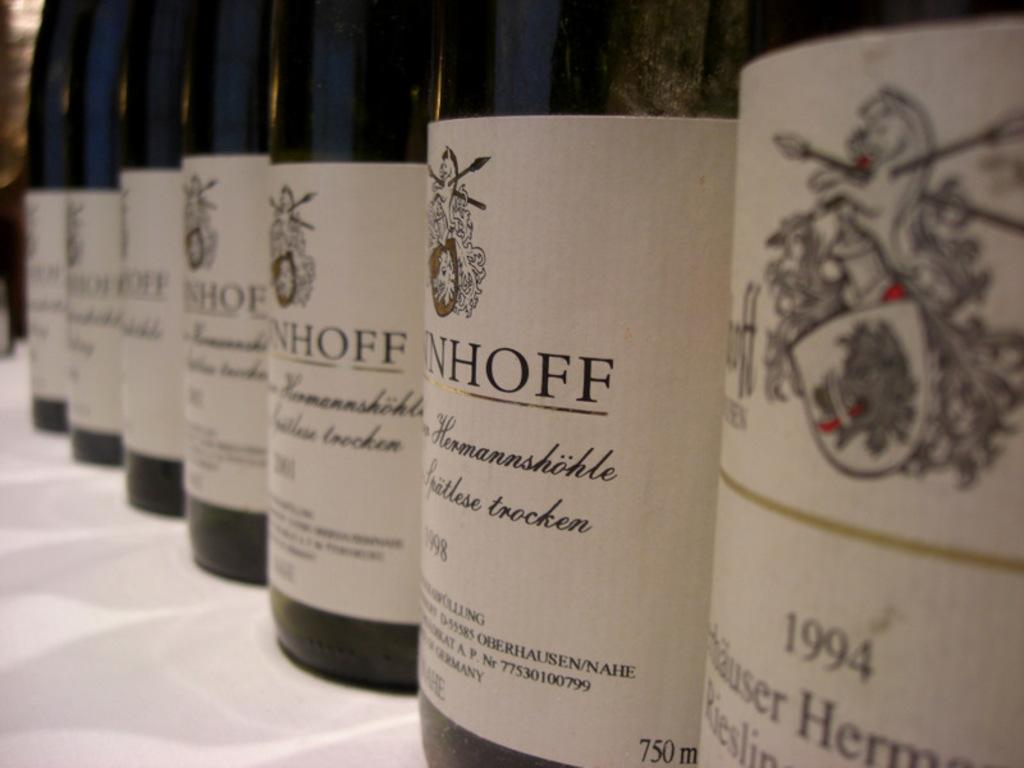<image>
Give a short and clear explanation of the subsequent image. a 1994 bottle that is on a white surface 